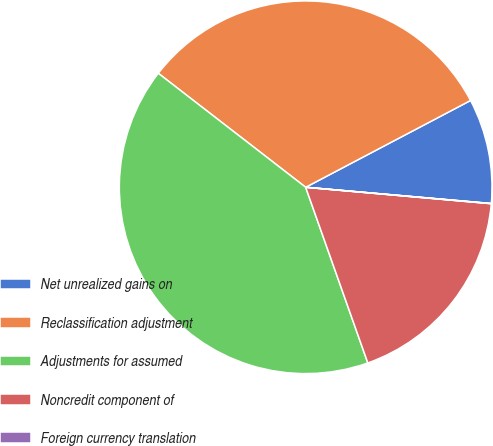Convert chart to OTSL. <chart><loc_0><loc_0><loc_500><loc_500><pie_chart><fcel>Net unrealized gains on<fcel>Reclassification adjustment<fcel>Adjustments for assumed<fcel>Noncredit component of<fcel>Foreign currency translation<nl><fcel>9.1%<fcel>31.81%<fcel>40.89%<fcel>18.18%<fcel>0.02%<nl></chart> 